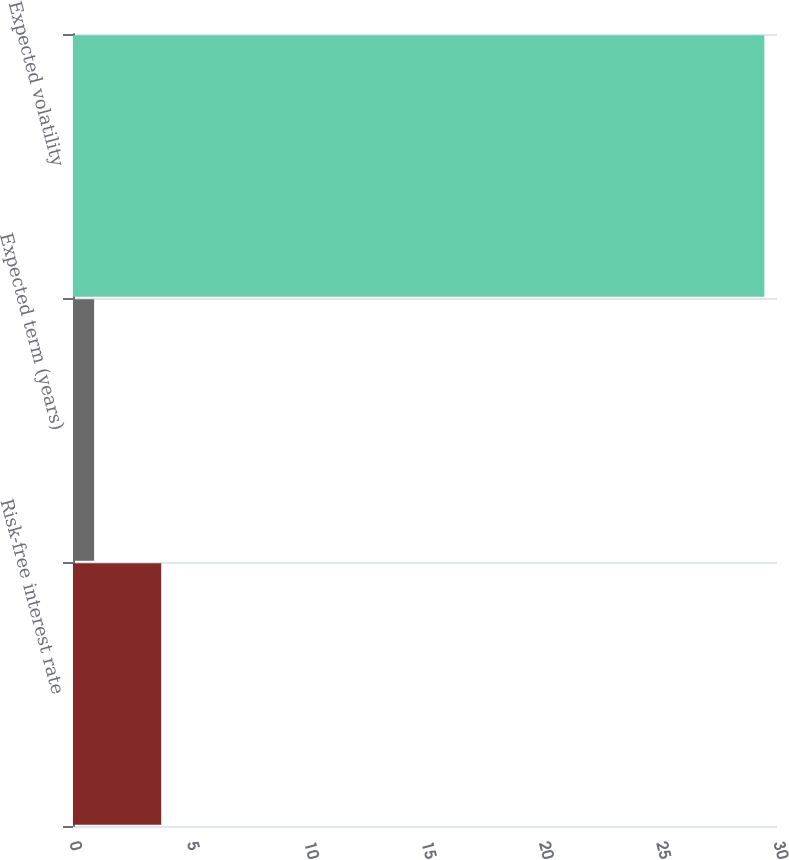Convert chart to OTSL. <chart><loc_0><loc_0><loc_500><loc_500><bar_chart><fcel>Risk-free interest rate<fcel>Expected term (years)<fcel>Expected volatility<nl><fcel>3.76<fcel>0.9<fcel>29.46<nl></chart> 